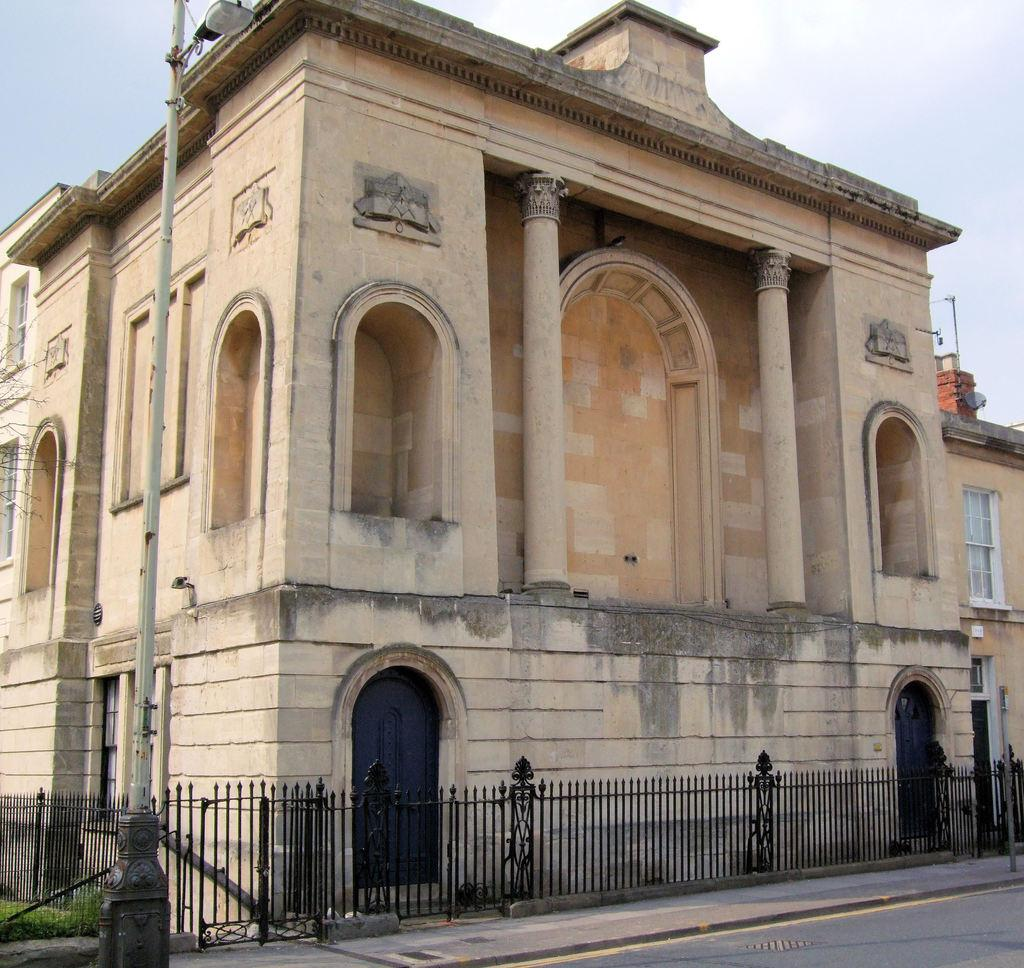What is the main structure in the center of the image? There is a building in the center of the image. What other architectural features can be seen in the image? There is a wall, a fence, pillars, doors, and poles in the image. What type of ground surface is visible in the image? There is grass and a road in the image. What can be seen in the background of the image? The sky is visible in the background of the image, with clouds present. What type of cheese is being used to build the wall in the image? There is no cheese present in the image; the wall is made of a solid material, not food. 